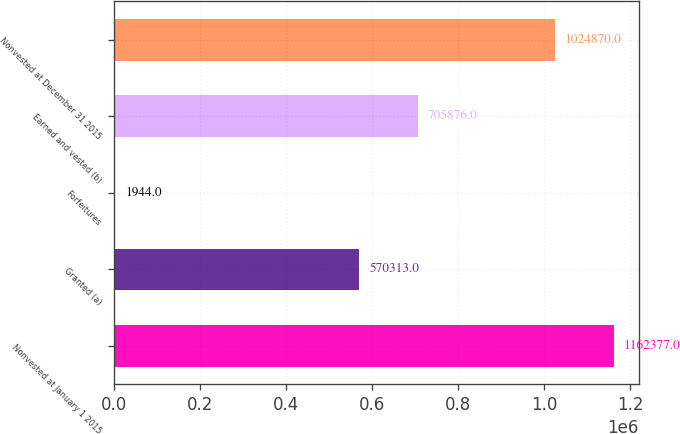Convert chart to OTSL. <chart><loc_0><loc_0><loc_500><loc_500><bar_chart><fcel>Nonvested at January 1 2015<fcel>Granted (a)<fcel>Forfeitures<fcel>Earned and vested (b)<fcel>Nonvested at December 31 2015<nl><fcel>1.16238e+06<fcel>570313<fcel>1944<fcel>705876<fcel>1.02487e+06<nl></chart> 